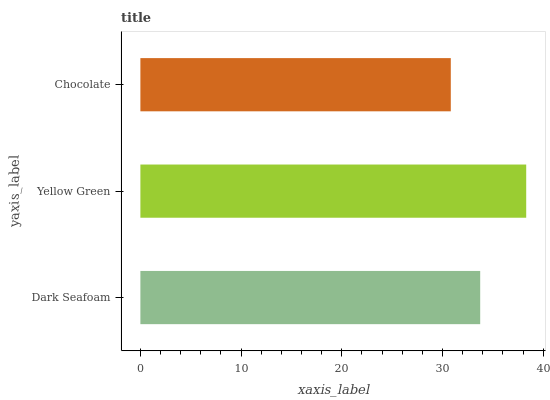Is Chocolate the minimum?
Answer yes or no. Yes. Is Yellow Green the maximum?
Answer yes or no. Yes. Is Yellow Green the minimum?
Answer yes or no. No. Is Chocolate the maximum?
Answer yes or no. No. Is Yellow Green greater than Chocolate?
Answer yes or no. Yes. Is Chocolate less than Yellow Green?
Answer yes or no. Yes. Is Chocolate greater than Yellow Green?
Answer yes or no. No. Is Yellow Green less than Chocolate?
Answer yes or no. No. Is Dark Seafoam the high median?
Answer yes or no. Yes. Is Dark Seafoam the low median?
Answer yes or no. Yes. Is Yellow Green the high median?
Answer yes or no. No. Is Yellow Green the low median?
Answer yes or no. No. 